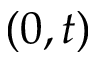<formula> <loc_0><loc_0><loc_500><loc_500>( 0 , t )</formula> 